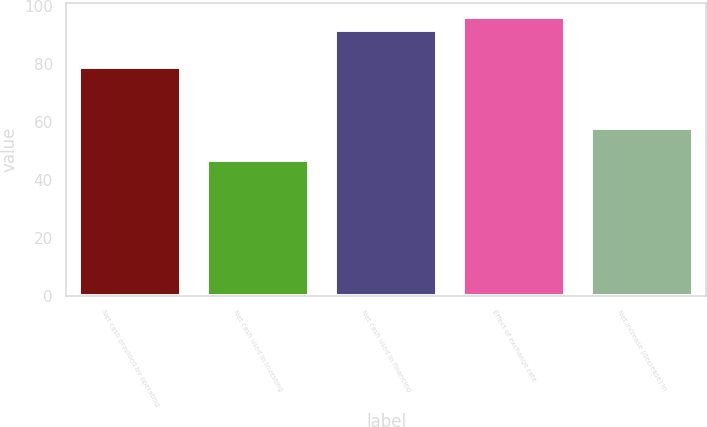<chart> <loc_0><loc_0><loc_500><loc_500><bar_chart><fcel>Net cash provided by operating<fcel>Net cash used in investing<fcel>Net cash used in financing<fcel>Effect of exchange rate<fcel>Net increase (decrease) in<nl><fcel>78.8<fcel>47<fcel>91.6<fcel>96.11<fcel>57.9<nl></chart> 